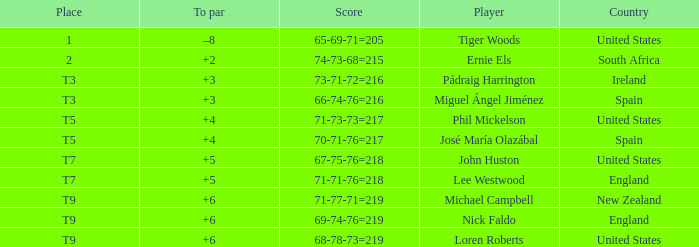What is To Par, when Place is "T5", and when Country is "United States"? 4.0. 